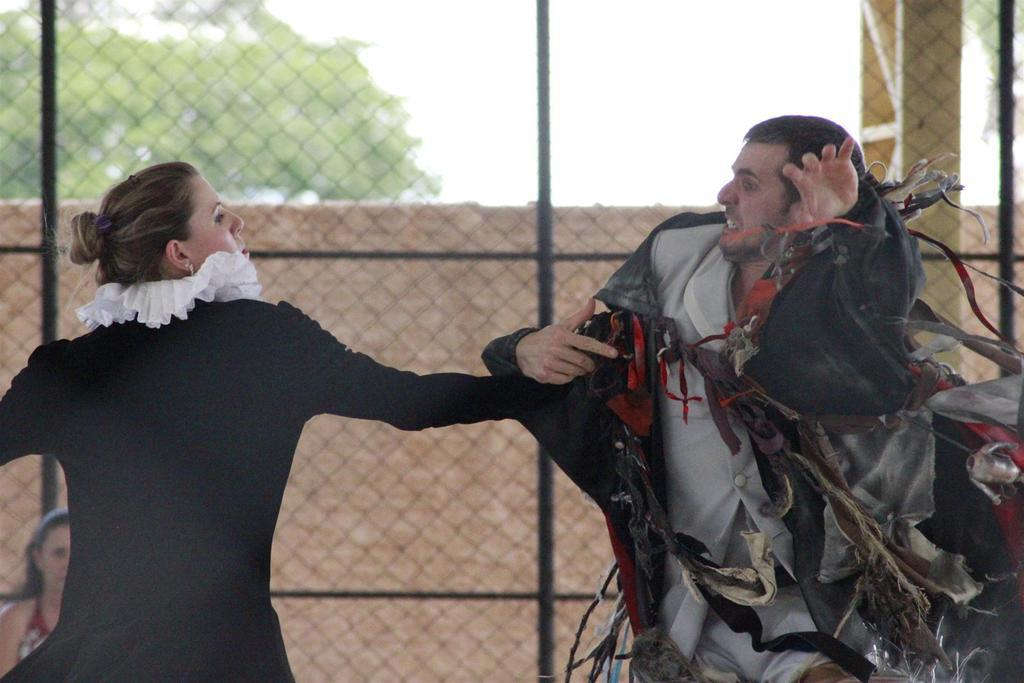How many people are present in the image? There are two people, a man and a woman, present in the image. What are the man and woman doing in the image? The man and woman are standing in the image. What can be seen in the background of the image? There are trees and sky visible in the background of the image. What type of material is present in the image? There is an iron mesh in the image. What type of cushion can be seen on the bird's head in the image? There is no bird or cushion present in the image. What type of pleasure can be seen on the man's face in the image? The image does not provide information about the man's emotions or pleasure. 